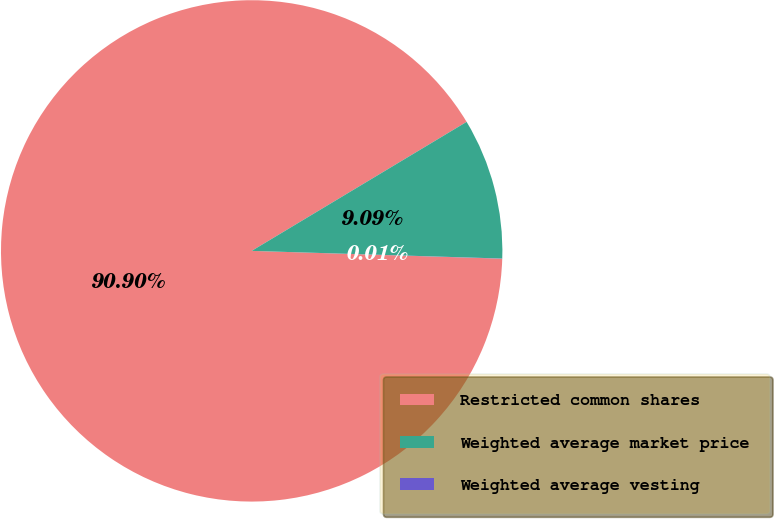Convert chart. <chart><loc_0><loc_0><loc_500><loc_500><pie_chart><fcel>Restricted common shares<fcel>Weighted average market price<fcel>Weighted average vesting<nl><fcel>90.9%<fcel>9.09%<fcel>0.01%<nl></chart> 